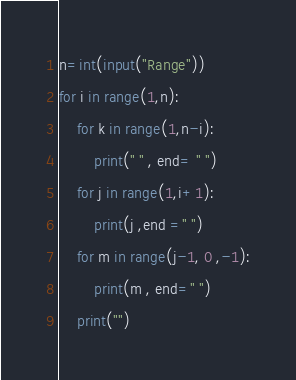<code> <loc_0><loc_0><loc_500><loc_500><_Python_>n=int(input("Range"))
for i in range(1,n):
	for k in range(1,n-i):
		print(" " , end= " ")
	for j in range(1,i+1):
		print(j ,end =" ")
	for m in range(j-1, 0 ,-1):
		print(m , end=" ")
	print("")</code> 